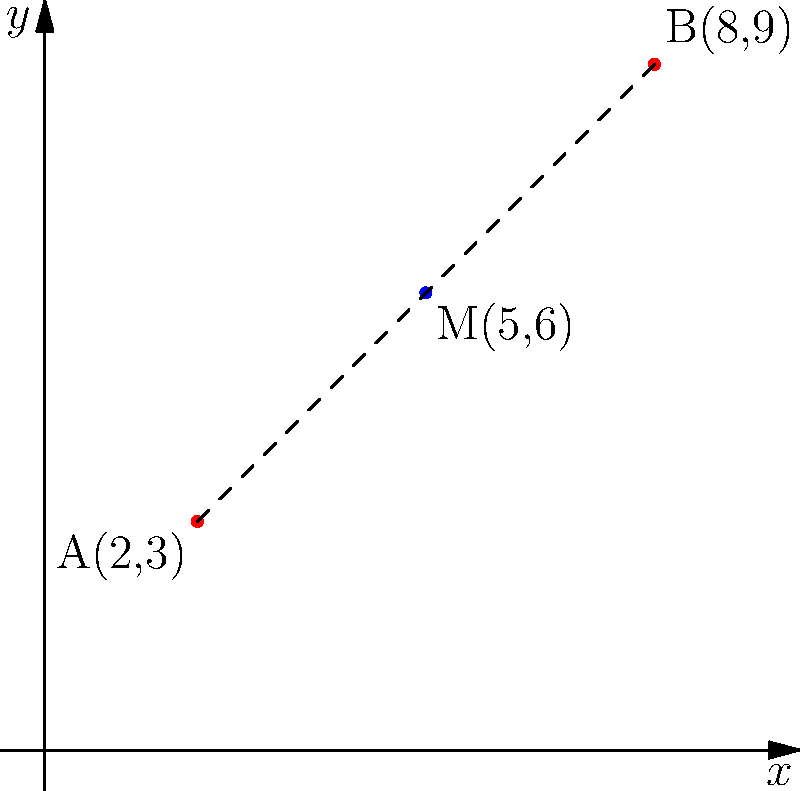Two veterans groups have proposed different locations for a new memorial. Group A suggests the coordinates (2,3), while Group B prefers (8,9). To find a compromise, you decide to locate the memorial at the midpoint between these two locations. What are the coordinates of this optimal location for the veterans' memorial? To find the midpoint between two coordinates, we use the midpoint formula:

$$ \text{Midpoint} = \left(\frac{x_1 + x_2}{2}, \frac{y_1 + y_2}{2}\right) $$

Where $(x_1, y_1)$ is the first point and $(x_2, y_2)$ is the second point.

Given:
- Point A: (2, 3)
- Point B: (8, 9)

Step 1: Calculate the x-coordinate of the midpoint:
$$ x = \frac{x_1 + x_2}{2} = \frac{2 + 8}{2} = \frac{10}{2} = 5 $$

Step 2: Calculate the y-coordinate of the midpoint:
$$ y = \frac{y_1 + y_2}{2} = \frac{3 + 9}{2} = \frac{12}{2} = 6 $$

Therefore, the midpoint and optimal location for the veterans' memorial is (5, 6).
Answer: (5, 6) 